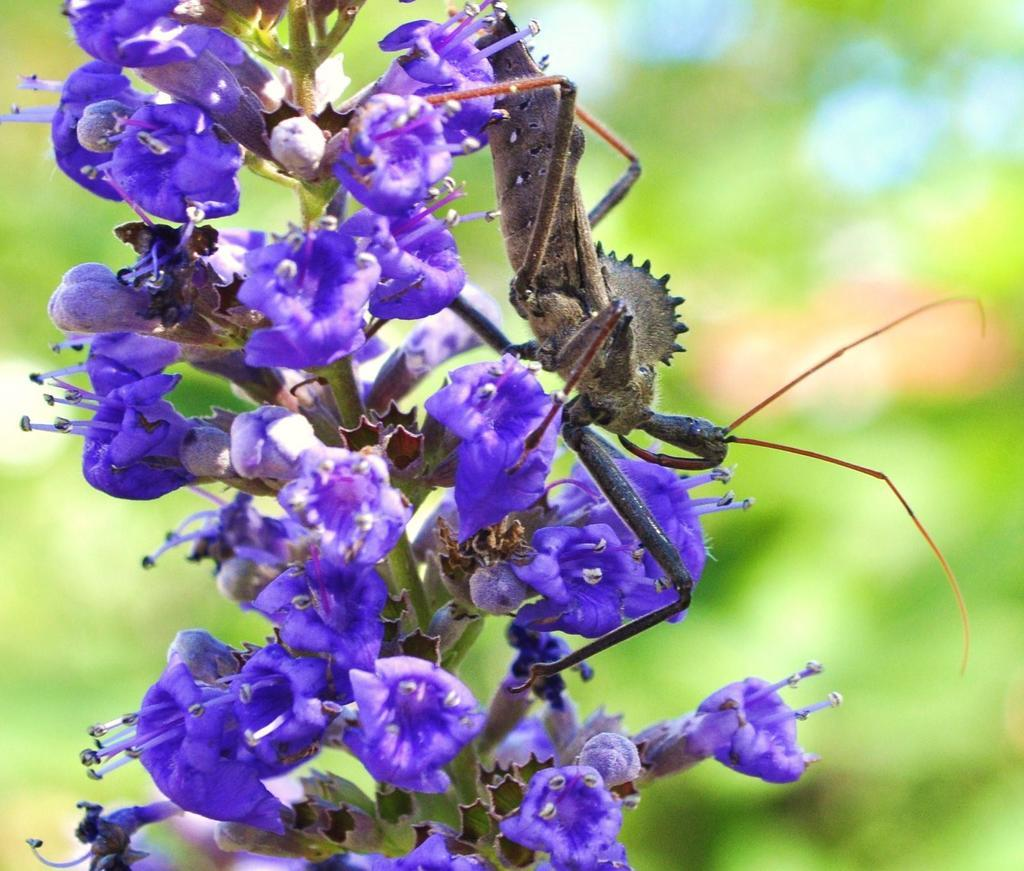What is the main subject of the image? There is a group of flowers in the image. Can you describe any specific details about the flowers? There are buds on the stem of a plant in the image. Are there any other living organisms present in the image? Yes, there is an insect on a flower in the image. How would you describe the background of the image? The background of the image is blurred. What type of lettuce can be seen growing in the background of the image? There is no lettuce present in the image; it features a group of flowers with an insect on one of the flowers. 